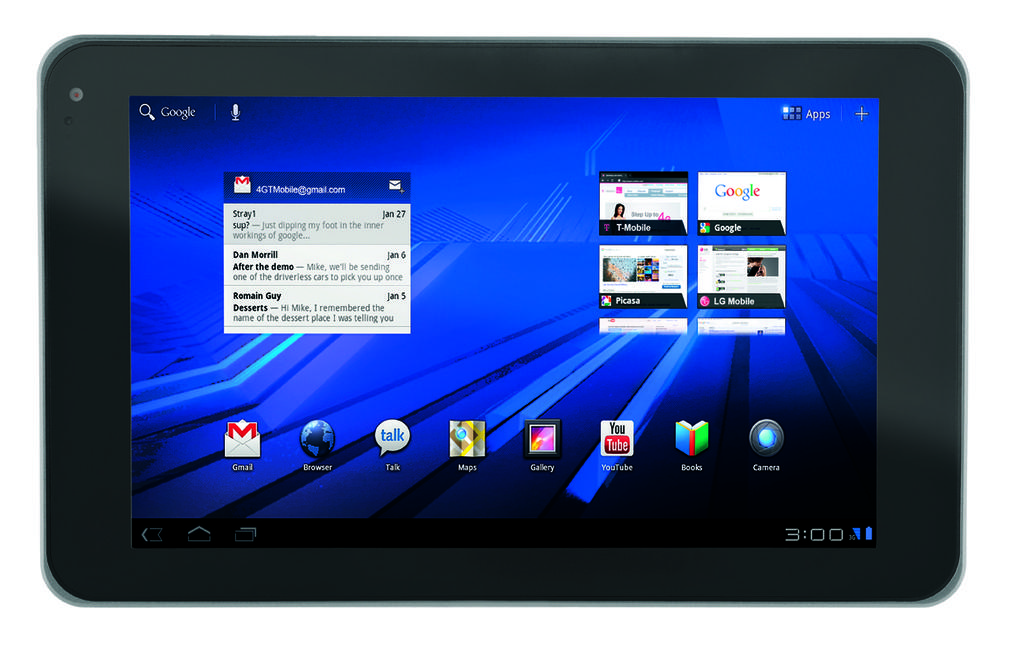What is the main object in the image? There is a screen in the image. What can be seen on the screen? There is text visible on the screen. How many toes are visible on the screen in the image? There are no toes visible on the screen in the image. What is the price of the item being displayed on the screen? There is no price information visible on the screen in the image. 